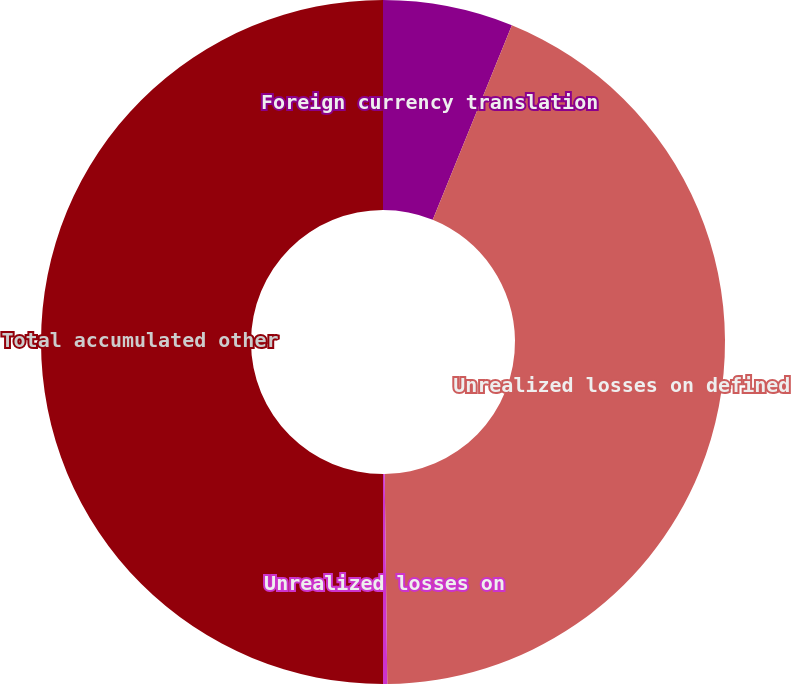Convert chart to OTSL. <chart><loc_0><loc_0><loc_500><loc_500><pie_chart><fcel>Foreign currency translation<fcel>Unrealized losses on defined<fcel>Unrealized losses on<fcel>Total accumulated other<nl><fcel>6.15%<fcel>43.65%<fcel>0.2%<fcel>50.0%<nl></chart> 